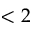<formula> <loc_0><loc_0><loc_500><loc_500>< 2</formula> 